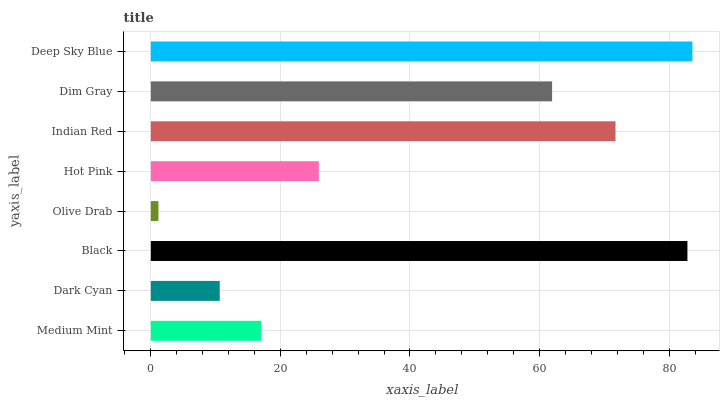Is Olive Drab the minimum?
Answer yes or no. Yes. Is Deep Sky Blue the maximum?
Answer yes or no. Yes. Is Dark Cyan the minimum?
Answer yes or no. No. Is Dark Cyan the maximum?
Answer yes or no. No. Is Medium Mint greater than Dark Cyan?
Answer yes or no. Yes. Is Dark Cyan less than Medium Mint?
Answer yes or no. Yes. Is Dark Cyan greater than Medium Mint?
Answer yes or no. No. Is Medium Mint less than Dark Cyan?
Answer yes or no. No. Is Dim Gray the high median?
Answer yes or no. Yes. Is Hot Pink the low median?
Answer yes or no. Yes. Is Hot Pink the high median?
Answer yes or no. No. Is Dark Cyan the low median?
Answer yes or no. No. 